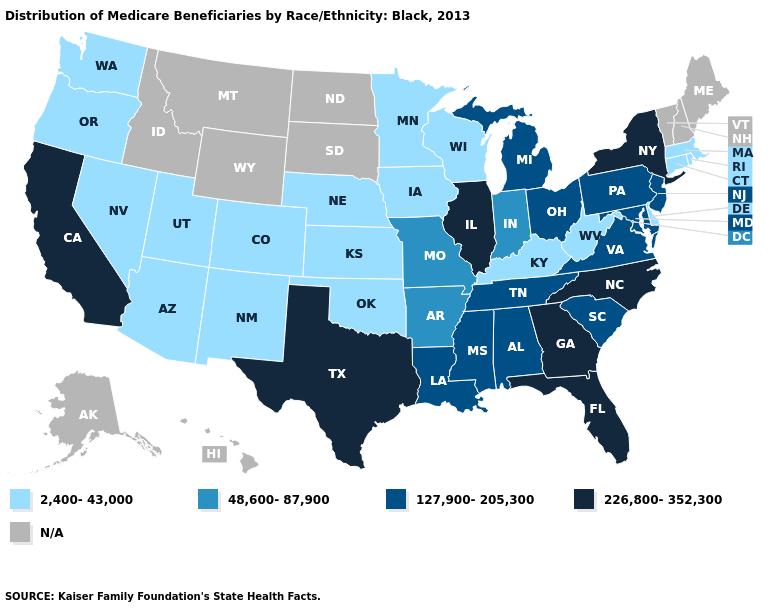What is the highest value in states that border California?
Be succinct. 2,400-43,000. Does Oklahoma have the highest value in the USA?
Write a very short answer. No. Does the first symbol in the legend represent the smallest category?
Quick response, please. Yes. Name the states that have a value in the range 48,600-87,900?
Concise answer only. Arkansas, Indiana, Missouri. Name the states that have a value in the range 226,800-352,300?
Answer briefly. California, Florida, Georgia, Illinois, New York, North Carolina, Texas. What is the lowest value in the West?
Keep it brief. 2,400-43,000. What is the value of Indiana?
Answer briefly. 48,600-87,900. What is the value of Oregon?
Answer briefly. 2,400-43,000. Does West Virginia have the highest value in the USA?
Answer briefly. No. What is the highest value in the South ?
Answer briefly. 226,800-352,300. Does North Carolina have the highest value in the South?
Keep it brief. Yes. Does Connecticut have the lowest value in the Northeast?
Concise answer only. Yes. What is the value of Oregon?
Quick response, please. 2,400-43,000. Name the states that have a value in the range 2,400-43,000?
Concise answer only. Arizona, Colorado, Connecticut, Delaware, Iowa, Kansas, Kentucky, Massachusetts, Minnesota, Nebraska, Nevada, New Mexico, Oklahoma, Oregon, Rhode Island, Utah, Washington, West Virginia, Wisconsin. 